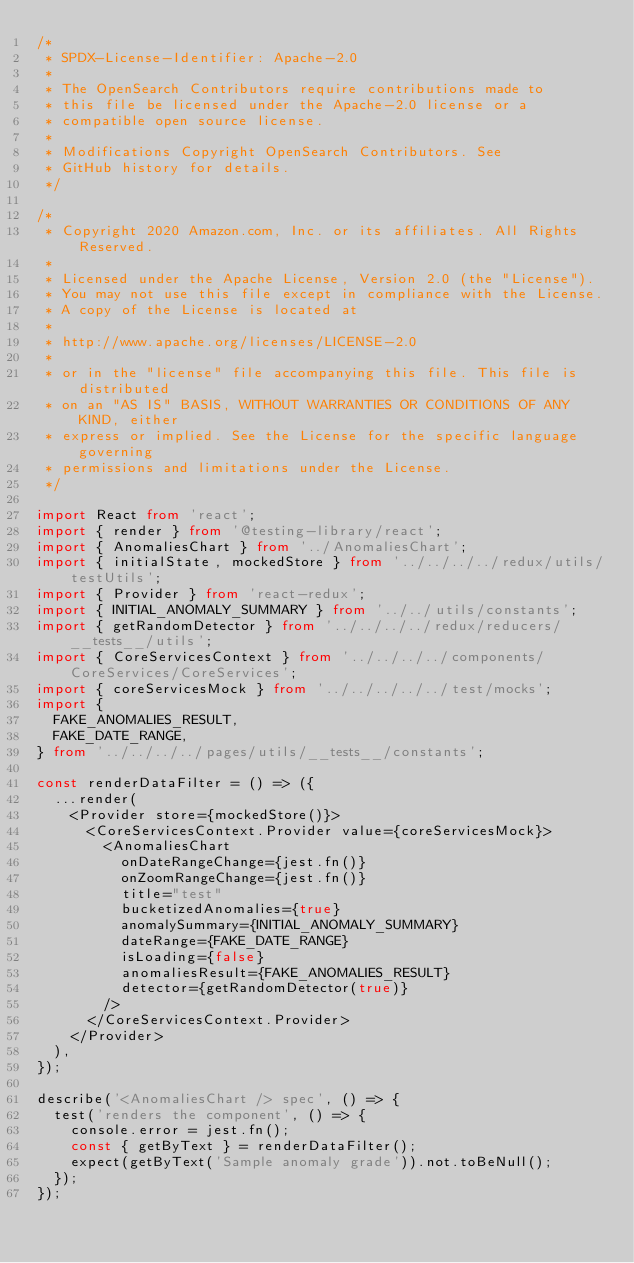<code> <loc_0><loc_0><loc_500><loc_500><_TypeScript_>/*
 * SPDX-License-Identifier: Apache-2.0
 *
 * The OpenSearch Contributors require contributions made to
 * this file be licensed under the Apache-2.0 license or a
 * compatible open source license.
 *
 * Modifications Copyright OpenSearch Contributors. See
 * GitHub history for details.
 */

/*
 * Copyright 2020 Amazon.com, Inc. or its affiliates. All Rights Reserved.
 *
 * Licensed under the Apache License, Version 2.0 (the "License").
 * You may not use this file except in compliance with the License.
 * A copy of the License is located at
 *
 * http://www.apache.org/licenses/LICENSE-2.0
 *
 * or in the "license" file accompanying this file. This file is distributed
 * on an "AS IS" BASIS, WITHOUT WARRANTIES OR CONDITIONS OF ANY KIND, either
 * express or implied. See the License for the specific language governing
 * permissions and limitations under the License.
 */

import React from 'react';
import { render } from '@testing-library/react';
import { AnomaliesChart } from '../AnomaliesChart';
import { initialState, mockedStore } from '../../../../redux/utils/testUtils';
import { Provider } from 'react-redux';
import { INITIAL_ANOMALY_SUMMARY } from '../../utils/constants';
import { getRandomDetector } from '../../../../redux/reducers/__tests__/utils';
import { CoreServicesContext } from '../../../../components/CoreServices/CoreServices';
import { coreServicesMock } from '../../../../../test/mocks';
import {
  FAKE_ANOMALIES_RESULT,
  FAKE_DATE_RANGE,
} from '../../../../pages/utils/__tests__/constants';

const renderDataFilter = () => ({
  ...render(
    <Provider store={mockedStore()}>
      <CoreServicesContext.Provider value={coreServicesMock}>
        <AnomaliesChart
          onDateRangeChange={jest.fn()}
          onZoomRangeChange={jest.fn()}
          title="test"
          bucketizedAnomalies={true}
          anomalySummary={INITIAL_ANOMALY_SUMMARY}
          dateRange={FAKE_DATE_RANGE}
          isLoading={false}
          anomaliesResult={FAKE_ANOMALIES_RESULT}
          detector={getRandomDetector(true)}
        />
      </CoreServicesContext.Provider>
    </Provider>
  ),
});

describe('<AnomaliesChart /> spec', () => {
  test('renders the component', () => {
    console.error = jest.fn();
    const { getByText } = renderDataFilter();
    expect(getByText('Sample anomaly grade')).not.toBeNull();
  });
});
</code> 